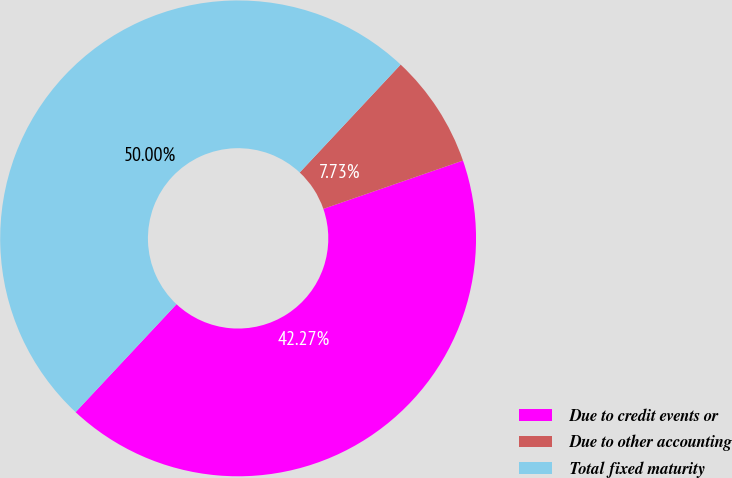Convert chart. <chart><loc_0><loc_0><loc_500><loc_500><pie_chart><fcel>Due to credit events or<fcel>Due to other accounting<fcel>Total fixed maturity<nl><fcel>42.27%<fcel>7.73%<fcel>50.0%<nl></chart> 